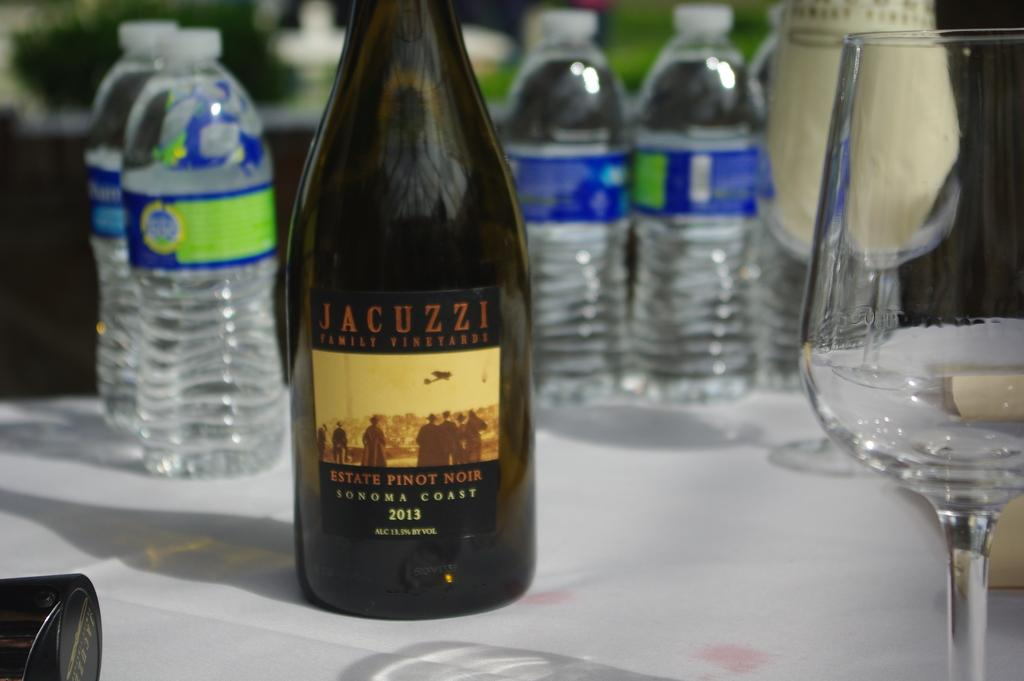<image>
Render a clear and concise summary of the photo. a bottle of Jacuzzi Pinot Noir 2013 on a white table 